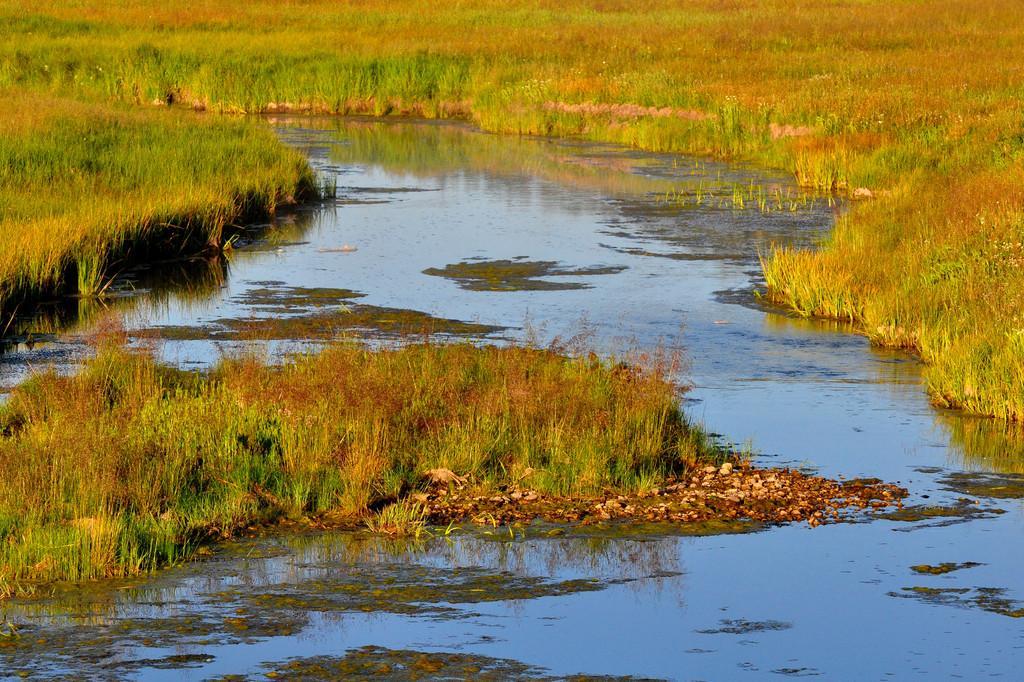Could you give a brief overview of what you see in this image? In this image there is a water surface, on either side of the water surface there is grassland. 